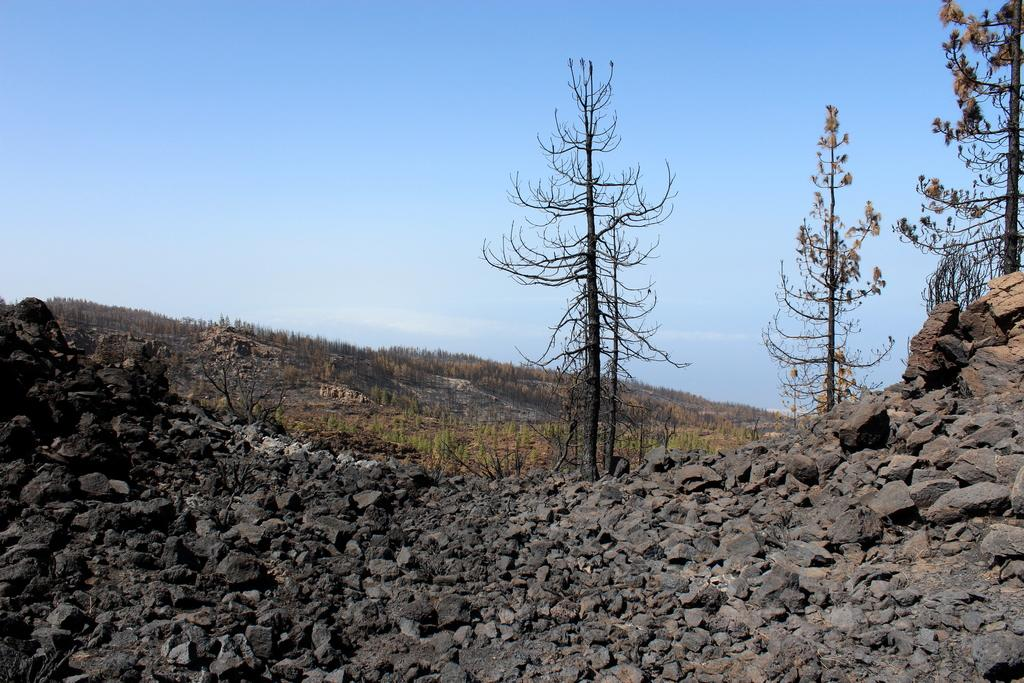What type of natural elements can be seen in the front of the image? There are rocks in the front of the image. What type of natural elements can be seen in the background of the image? There are trees in the background of the image. What else can be seen in the background of the image? The sky is visible in the background of the image. How many flowers are growing on the rocks in the image? There are no flowers present in the image; it features rocks and trees. Are there any tomatoes visible on the trees in the image? There are no tomatoes present in the image; it features rocks and trees. 